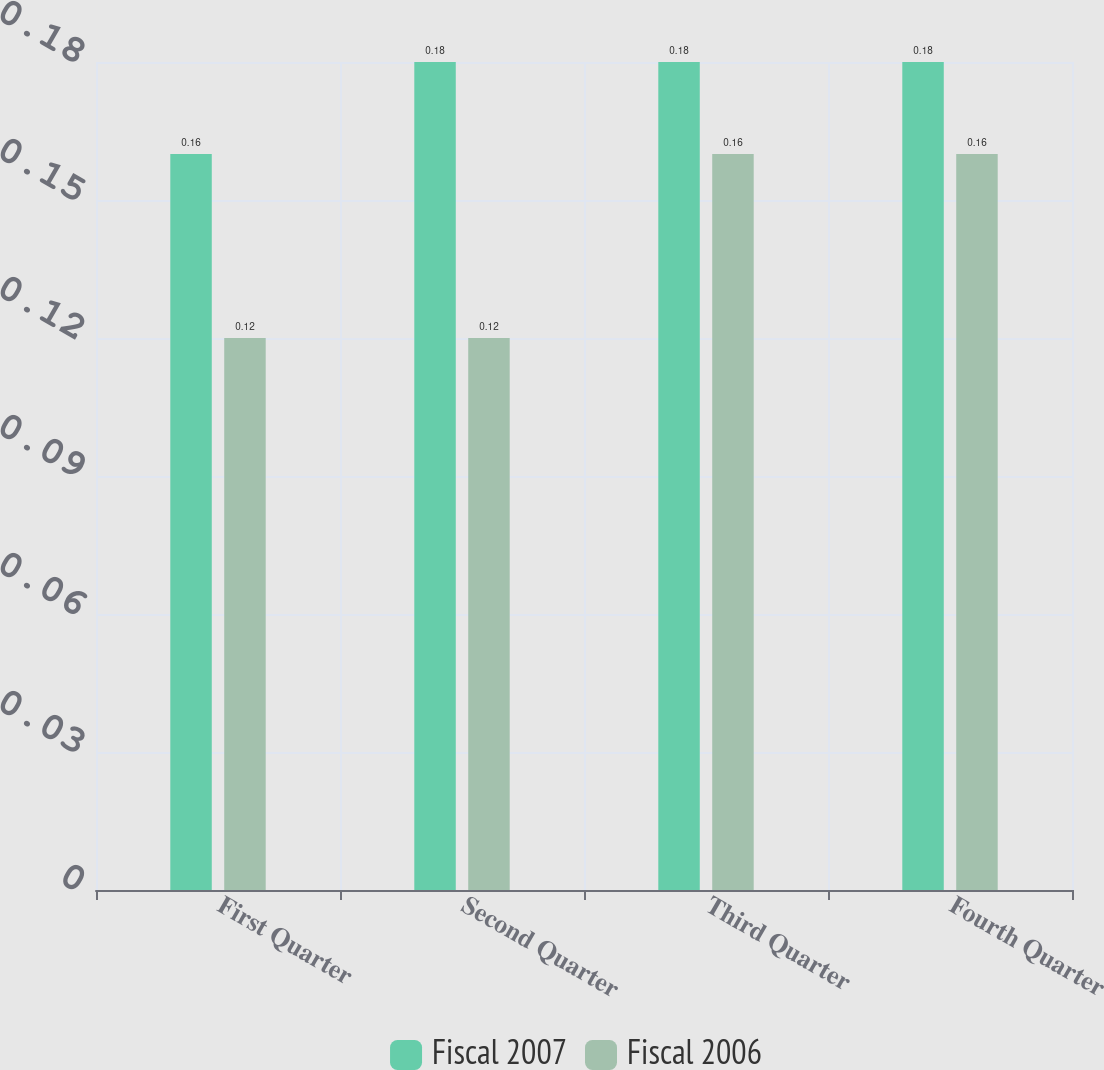Convert chart. <chart><loc_0><loc_0><loc_500><loc_500><stacked_bar_chart><ecel><fcel>First Quarter<fcel>Second Quarter<fcel>Third Quarter<fcel>Fourth Quarter<nl><fcel>Fiscal 2007<fcel>0.16<fcel>0.18<fcel>0.18<fcel>0.18<nl><fcel>Fiscal 2006<fcel>0.12<fcel>0.12<fcel>0.16<fcel>0.16<nl></chart> 